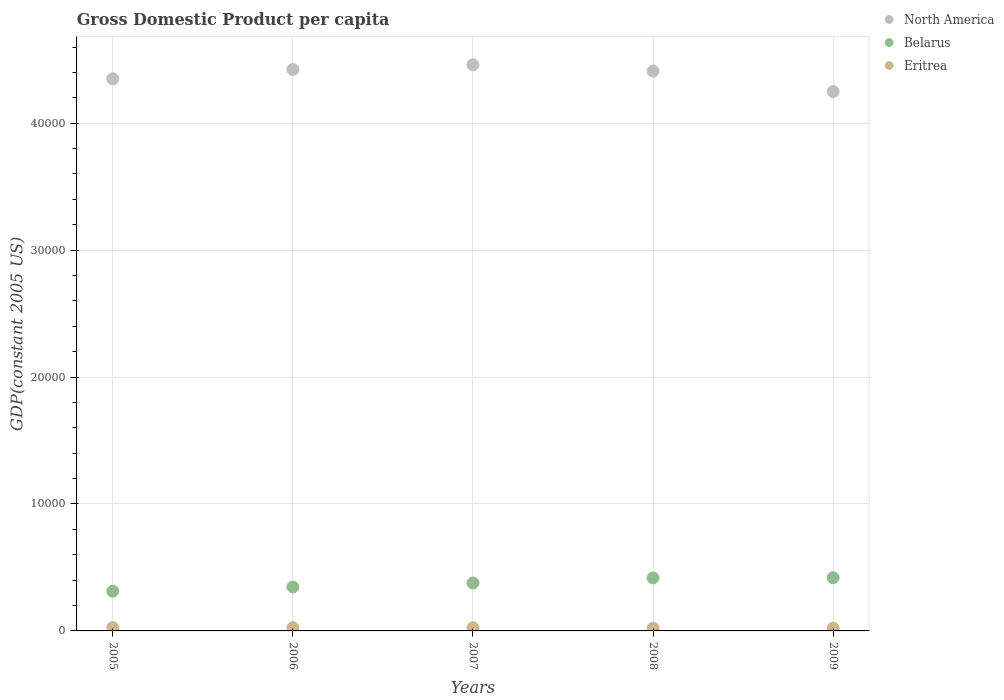Is the number of dotlines equal to the number of legend labels?
Your response must be concise. Yes. What is the GDP per capita in North America in 2005?
Provide a short and direct response. 4.35e+04. Across all years, what is the maximum GDP per capita in Eritrea?
Offer a very short reply. 262.07. Across all years, what is the minimum GDP per capita in Belarus?
Your answer should be compact. 3126.37. What is the total GDP per capita in Belarus in the graph?
Your answer should be compact. 1.87e+04. What is the difference between the GDP per capita in Eritrea in 2008 and that in 2009?
Your answer should be very brief. -3.93. What is the difference between the GDP per capita in Eritrea in 2006 and the GDP per capita in Belarus in 2009?
Offer a terse response. -3938.89. What is the average GDP per capita in North America per year?
Offer a terse response. 4.38e+04. In the year 2006, what is the difference between the GDP per capita in North America and GDP per capita in Eritrea?
Provide a succinct answer. 4.40e+04. In how many years, is the GDP per capita in Belarus greater than 26000 US$?
Provide a succinct answer. 0. What is the ratio of the GDP per capita in North America in 2008 to that in 2009?
Make the answer very short. 1.04. Is the difference between the GDP per capita in North America in 2006 and 2009 greater than the difference between the GDP per capita in Eritrea in 2006 and 2009?
Offer a terse response. Yes. What is the difference between the highest and the second highest GDP per capita in Eritrea?
Your answer should be very brief. 9.36. What is the difference between the highest and the lowest GDP per capita in Eritrea?
Your answer should be very brief. 40.91. In how many years, is the GDP per capita in North America greater than the average GDP per capita in North America taken over all years?
Keep it short and to the point. 3. Is the GDP per capita in North America strictly less than the GDP per capita in Eritrea over the years?
Give a very brief answer. No. How many dotlines are there?
Ensure brevity in your answer.  3. Are the values on the major ticks of Y-axis written in scientific E-notation?
Provide a short and direct response. No. Does the graph contain any zero values?
Offer a very short reply. No. Where does the legend appear in the graph?
Your response must be concise. Top right. How many legend labels are there?
Give a very brief answer. 3. What is the title of the graph?
Your answer should be very brief. Gross Domestic Product per capita. Does "Kenya" appear as one of the legend labels in the graph?
Keep it short and to the point. No. What is the label or title of the X-axis?
Offer a very short reply. Years. What is the label or title of the Y-axis?
Give a very brief answer. GDP(constant 2005 US). What is the GDP(constant 2005 US) in North America in 2005?
Keep it short and to the point. 4.35e+04. What is the GDP(constant 2005 US) of Belarus in 2005?
Offer a very short reply. 3126.37. What is the GDP(constant 2005 US) of Eritrea in 2005?
Your answer should be very brief. 262.07. What is the GDP(constant 2005 US) of North America in 2006?
Offer a terse response. 4.42e+04. What is the GDP(constant 2005 US) in Belarus in 2006?
Provide a succinct answer. 3460.13. What is the GDP(constant 2005 US) in Eritrea in 2006?
Provide a succinct answer. 252.71. What is the GDP(constant 2005 US) of North America in 2007?
Make the answer very short. 4.46e+04. What is the GDP(constant 2005 US) in Belarus in 2007?
Offer a terse response. 3775. What is the GDP(constant 2005 US) in Eritrea in 2007?
Your answer should be compact. 250.39. What is the GDP(constant 2005 US) in North America in 2008?
Provide a short and direct response. 4.41e+04. What is the GDP(constant 2005 US) in Belarus in 2008?
Keep it short and to the point. 4174.02. What is the GDP(constant 2005 US) in Eritrea in 2008?
Offer a terse response. 221.16. What is the GDP(constant 2005 US) of North America in 2009?
Provide a short and direct response. 4.25e+04. What is the GDP(constant 2005 US) of Belarus in 2009?
Provide a succinct answer. 4191.61. What is the GDP(constant 2005 US) of Eritrea in 2009?
Give a very brief answer. 225.09. Across all years, what is the maximum GDP(constant 2005 US) of North America?
Offer a very short reply. 4.46e+04. Across all years, what is the maximum GDP(constant 2005 US) in Belarus?
Your answer should be compact. 4191.61. Across all years, what is the maximum GDP(constant 2005 US) in Eritrea?
Your response must be concise. 262.07. Across all years, what is the minimum GDP(constant 2005 US) of North America?
Your answer should be very brief. 4.25e+04. Across all years, what is the minimum GDP(constant 2005 US) of Belarus?
Your answer should be compact. 3126.37. Across all years, what is the minimum GDP(constant 2005 US) of Eritrea?
Offer a terse response. 221.16. What is the total GDP(constant 2005 US) in North America in the graph?
Your answer should be very brief. 2.19e+05. What is the total GDP(constant 2005 US) of Belarus in the graph?
Give a very brief answer. 1.87e+04. What is the total GDP(constant 2005 US) in Eritrea in the graph?
Ensure brevity in your answer.  1211.42. What is the difference between the GDP(constant 2005 US) of North America in 2005 and that in 2006?
Keep it short and to the point. -737.56. What is the difference between the GDP(constant 2005 US) of Belarus in 2005 and that in 2006?
Your response must be concise. -333.76. What is the difference between the GDP(constant 2005 US) in Eritrea in 2005 and that in 2006?
Your response must be concise. 9.36. What is the difference between the GDP(constant 2005 US) of North America in 2005 and that in 2007?
Give a very brief answer. -1105.75. What is the difference between the GDP(constant 2005 US) in Belarus in 2005 and that in 2007?
Make the answer very short. -648.63. What is the difference between the GDP(constant 2005 US) of Eritrea in 2005 and that in 2007?
Offer a very short reply. 11.68. What is the difference between the GDP(constant 2005 US) of North America in 2005 and that in 2008?
Provide a short and direct response. -604.38. What is the difference between the GDP(constant 2005 US) in Belarus in 2005 and that in 2008?
Offer a terse response. -1047.65. What is the difference between the GDP(constant 2005 US) in Eritrea in 2005 and that in 2008?
Offer a very short reply. 40.91. What is the difference between the GDP(constant 2005 US) in North America in 2005 and that in 2009?
Keep it short and to the point. 1003.24. What is the difference between the GDP(constant 2005 US) in Belarus in 2005 and that in 2009?
Your response must be concise. -1065.24. What is the difference between the GDP(constant 2005 US) of Eritrea in 2005 and that in 2009?
Make the answer very short. 36.99. What is the difference between the GDP(constant 2005 US) of North America in 2006 and that in 2007?
Keep it short and to the point. -368.19. What is the difference between the GDP(constant 2005 US) in Belarus in 2006 and that in 2007?
Your answer should be compact. -314.87. What is the difference between the GDP(constant 2005 US) in Eritrea in 2006 and that in 2007?
Provide a succinct answer. 2.32. What is the difference between the GDP(constant 2005 US) in North America in 2006 and that in 2008?
Keep it short and to the point. 133.18. What is the difference between the GDP(constant 2005 US) in Belarus in 2006 and that in 2008?
Keep it short and to the point. -713.89. What is the difference between the GDP(constant 2005 US) in Eritrea in 2006 and that in 2008?
Give a very brief answer. 31.55. What is the difference between the GDP(constant 2005 US) of North America in 2006 and that in 2009?
Provide a succinct answer. 1740.8. What is the difference between the GDP(constant 2005 US) in Belarus in 2006 and that in 2009?
Offer a very short reply. -731.47. What is the difference between the GDP(constant 2005 US) of Eritrea in 2006 and that in 2009?
Give a very brief answer. 27.62. What is the difference between the GDP(constant 2005 US) in North America in 2007 and that in 2008?
Give a very brief answer. 501.37. What is the difference between the GDP(constant 2005 US) of Belarus in 2007 and that in 2008?
Provide a succinct answer. -399.02. What is the difference between the GDP(constant 2005 US) of Eritrea in 2007 and that in 2008?
Your answer should be compact. 29.23. What is the difference between the GDP(constant 2005 US) of North America in 2007 and that in 2009?
Your response must be concise. 2108.99. What is the difference between the GDP(constant 2005 US) of Belarus in 2007 and that in 2009?
Offer a very short reply. -416.61. What is the difference between the GDP(constant 2005 US) in Eritrea in 2007 and that in 2009?
Ensure brevity in your answer.  25.3. What is the difference between the GDP(constant 2005 US) of North America in 2008 and that in 2009?
Your response must be concise. 1607.62. What is the difference between the GDP(constant 2005 US) of Belarus in 2008 and that in 2009?
Provide a short and direct response. -17.59. What is the difference between the GDP(constant 2005 US) in Eritrea in 2008 and that in 2009?
Make the answer very short. -3.93. What is the difference between the GDP(constant 2005 US) in North America in 2005 and the GDP(constant 2005 US) in Belarus in 2006?
Ensure brevity in your answer.  4.00e+04. What is the difference between the GDP(constant 2005 US) of North America in 2005 and the GDP(constant 2005 US) of Eritrea in 2006?
Give a very brief answer. 4.32e+04. What is the difference between the GDP(constant 2005 US) of Belarus in 2005 and the GDP(constant 2005 US) of Eritrea in 2006?
Offer a very short reply. 2873.66. What is the difference between the GDP(constant 2005 US) of North America in 2005 and the GDP(constant 2005 US) of Belarus in 2007?
Your answer should be very brief. 3.97e+04. What is the difference between the GDP(constant 2005 US) in North America in 2005 and the GDP(constant 2005 US) in Eritrea in 2007?
Give a very brief answer. 4.32e+04. What is the difference between the GDP(constant 2005 US) in Belarus in 2005 and the GDP(constant 2005 US) in Eritrea in 2007?
Your answer should be compact. 2875.98. What is the difference between the GDP(constant 2005 US) of North America in 2005 and the GDP(constant 2005 US) of Belarus in 2008?
Offer a very short reply. 3.93e+04. What is the difference between the GDP(constant 2005 US) of North America in 2005 and the GDP(constant 2005 US) of Eritrea in 2008?
Your response must be concise. 4.33e+04. What is the difference between the GDP(constant 2005 US) of Belarus in 2005 and the GDP(constant 2005 US) of Eritrea in 2008?
Your response must be concise. 2905.21. What is the difference between the GDP(constant 2005 US) of North America in 2005 and the GDP(constant 2005 US) of Belarus in 2009?
Give a very brief answer. 3.93e+04. What is the difference between the GDP(constant 2005 US) in North America in 2005 and the GDP(constant 2005 US) in Eritrea in 2009?
Make the answer very short. 4.33e+04. What is the difference between the GDP(constant 2005 US) of Belarus in 2005 and the GDP(constant 2005 US) of Eritrea in 2009?
Offer a very short reply. 2901.28. What is the difference between the GDP(constant 2005 US) in North America in 2006 and the GDP(constant 2005 US) in Belarus in 2007?
Your response must be concise. 4.05e+04. What is the difference between the GDP(constant 2005 US) in North America in 2006 and the GDP(constant 2005 US) in Eritrea in 2007?
Your answer should be compact. 4.40e+04. What is the difference between the GDP(constant 2005 US) in Belarus in 2006 and the GDP(constant 2005 US) in Eritrea in 2007?
Give a very brief answer. 3209.74. What is the difference between the GDP(constant 2005 US) in North America in 2006 and the GDP(constant 2005 US) in Belarus in 2008?
Provide a succinct answer. 4.01e+04. What is the difference between the GDP(constant 2005 US) of North America in 2006 and the GDP(constant 2005 US) of Eritrea in 2008?
Provide a succinct answer. 4.40e+04. What is the difference between the GDP(constant 2005 US) of Belarus in 2006 and the GDP(constant 2005 US) of Eritrea in 2008?
Make the answer very short. 3238.97. What is the difference between the GDP(constant 2005 US) in North America in 2006 and the GDP(constant 2005 US) in Belarus in 2009?
Your response must be concise. 4.00e+04. What is the difference between the GDP(constant 2005 US) in North America in 2006 and the GDP(constant 2005 US) in Eritrea in 2009?
Offer a terse response. 4.40e+04. What is the difference between the GDP(constant 2005 US) of Belarus in 2006 and the GDP(constant 2005 US) of Eritrea in 2009?
Your answer should be compact. 3235.04. What is the difference between the GDP(constant 2005 US) of North America in 2007 and the GDP(constant 2005 US) of Belarus in 2008?
Ensure brevity in your answer.  4.04e+04. What is the difference between the GDP(constant 2005 US) in North America in 2007 and the GDP(constant 2005 US) in Eritrea in 2008?
Provide a succinct answer. 4.44e+04. What is the difference between the GDP(constant 2005 US) of Belarus in 2007 and the GDP(constant 2005 US) of Eritrea in 2008?
Offer a very short reply. 3553.84. What is the difference between the GDP(constant 2005 US) of North America in 2007 and the GDP(constant 2005 US) of Belarus in 2009?
Keep it short and to the point. 4.04e+04. What is the difference between the GDP(constant 2005 US) in North America in 2007 and the GDP(constant 2005 US) in Eritrea in 2009?
Offer a terse response. 4.44e+04. What is the difference between the GDP(constant 2005 US) of Belarus in 2007 and the GDP(constant 2005 US) of Eritrea in 2009?
Your answer should be very brief. 3549.91. What is the difference between the GDP(constant 2005 US) of North America in 2008 and the GDP(constant 2005 US) of Belarus in 2009?
Provide a succinct answer. 3.99e+04. What is the difference between the GDP(constant 2005 US) of North America in 2008 and the GDP(constant 2005 US) of Eritrea in 2009?
Keep it short and to the point. 4.39e+04. What is the difference between the GDP(constant 2005 US) in Belarus in 2008 and the GDP(constant 2005 US) in Eritrea in 2009?
Your response must be concise. 3948.93. What is the average GDP(constant 2005 US) in North America per year?
Your response must be concise. 4.38e+04. What is the average GDP(constant 2005 US) of Belarus per year?
Offer a very short reply. 3745.42. What is the average GDP(constant 2005 US) in Eritrea per year?
Keep it short and to the point. 242.28. In the year 2005, what is the difference between the GDP(constant 2005 US) of North America and GDP(constant 2005 US) of Belarus?
Your response must be concise. 4.04e+04. In the year 2005, what is the difference between the GDP(constant 2005 US) of North America and GDP(constant 2005 US) of Eritrea?
Your response must be concise. 4.32e+04. In the year 2005, what is the difference between the GDP(constant 2005 US) of Belarus and GDP(constant 2005 US) of Eritrea?
Offer a terse response. 2864.29. In the year 2006, what is the difference between the GDP(constant 2005 US) of North America and GDP(constant 2005 US) of Belarus?
Your answer should be very brief. 4.08e+04. In the year 2006, what is the difference between the GDP(constant 2005 US) in North America and GDP(constant 2005 US) in Eritrea?
Give a very brief answer. 4.40e+04. In the year 2006, what is the difference between the GDP(constant 2005 US) of Belarus and GDP(constant 2005 US) of Eritrea?
Keep it short and to the point. 3207.42. In the year 2007, what is the difference between the GDP(constant 2005 US) of North America and GDP(constant 2005 US) of Belarus?
Your response must be concise. 4.08e+04. In the year 2007, what is the difference between the GDP(constant 2005 US) of North America and GDP(constant 2005 US) of Eritrea?
Ensure brevity in your answer.  4.44e+04. In the year 2007, what is the difference between the GDP(constant 2005 US) of Belarus and GDP(constant 2005 US) of Eritrea?
Provide a short and direct response. 3524.61. In the year 2008, what is the difference between the GDP(constant 2005 US) of North America and GDP(constant 2005 US) of Belarus?
Offer a very short reply. 3.99e+04. In the year 2008, what is the difference between the GDP(constant 2005 US) in North America and GDP(constant 2005 US) in Eritrea?
Make the answer very short. 4.39e+04. In the year 2008, what is the difference between the GDP(constant 2005 US) in Belarus and GDP(constant 2005 US) in Eritrea?
Offer a terse response. 3952.86. In the year 2009, what is the difference between the GDP(constant 2005 US) of North America and GDP(constant 2005 US) of Belarus?
Ensure brevity in your answer.  3.83e+04. In the year 2009, what is the difference between the GDP(constant 2005 US) of North America and GDP(constant 2005 US) of Eritrea?
Provide a succinct answer. 4.23e+04. In the year 2009, what is the difference between the GDP(constant 2005 US) in Belarus and GDP(constant 2005 US) in Eritrea?
Offer a terse response. 3966.52. What is the ratio of the GDP(constant 2005 US) in North America in 2005 to that in 2006?
Offer a very short reply. 0.98. What is the ratio of the GDP(constant 2005 US) in Belarus in 2005 to that in 2006?
Your answer should be very brief. 0.9. What is the ratio of the GDP(constant 2005 US) in Eritrea in 2005 to that in 2006?
Make the answer very short. 1.04. What is the ratio of the GDP(constant 2005 US) of North America in 2005 to that in 2007?
Ensure brevity in your answer.  0.98. What is the ratio of the GDP(constant 2005 US) in Belarus in 2005 to that in 2007?
Provide a succinct answer. 0.83. What is the ratio of the GDP(constant 2005 US) of Eritrea in 2005 to that in 2007?
Offer a very short reply. 1.05. What is the ratio of the GDP(constant 2005 US) of North America in 2005 to that in 2008?
Your answer should be very brief. 0.99. What is the ratio of the GDP(constant 2005 US) of Belarus in 2005 to that in 2008?
Keep it short and to the point. 0.75. What is the ratio of the GDP(constant 2005 US) in Eritrea in 2005 to that in 2008?
Your response must be concise. 1.19. What is the ratio of the GDP(constant 2005 US) in North America in 2005 to that in 2009?
Your answer should be compact. 1.02. What is the ratio of the GDP(constant 2005 US) of Belarus in 2005 to that in 2009?
Provide a succinct answer. 0.75. What is the ratio of the GDP(constant 2005 US) in Eritrea in 2005 to that in 2009?
Ensure brevity in your answer.  1.16. What is the ratio of the GDP(constant 2005 US) in Belarus in 2006 to that in 2007?
Offer a terse response. 0.92. What is the ratio of the GDP(constant 2005 US) in Eritrea in 2006 to that in 2007?
Provide a succinct answer. 1.01. What is the ratio of the GDP(constant 2005 US) of North America in 2006 to that in 2008?
Keep it short and to the point. 1. What is the ratio of the GDP(constant 2005 US) of Belarus in 2006 to that in 2008?
Provide a succinct answer. 0.83. What is the ratio of the GDP(constant 2005 US) of Eritrea in 2006 to that in 2008?
Provide a short and direct response. 1.14. What is the ratio of the GDP(constant 2005 US) of North America in 2006 to that in 2009?
Provide a short and direct response. 1.04. What is the ratio of the GDP(constant 2005 US) in Belarus in 2006 to that in 2009?
Provide a short and direct response. 0.83. What is the ratio of the GDP(constant 2005 US) in Eritrea in 2006 to that in 2009?
Provide a succinct answer. 1.12. What is the ratio of the GDP(constant 2005 US) in North America in 2007 to that in 2008?
Give a very brief answer. 1.01. What is the ratio of the GDP(constant 2005 US) of Belarus in 2007 to that in 2008?
Your response must be concise. 0.9. What is the ratio of the GDP(constant 2005 US) in Eritrea in 2007 to that in 2008?
Keep it short and to the point. 1.13. What is the ratio of the GDP(constant 2005 US) of North America in 2007 to that in 2009?
Your response must be concise. 1.05. What is the ratio of the GDP(constant 2005 US) in Belarus in 2007 to that in 2009?
Provide a short and direct response. 0.9. What is the ratio of the GDP(constant 2005 US) in Eritrea in 2007 to that in 2009?
Give a very brief answer. 1.11. What is the ratio of the GDP(constant 2005 US) in North America in 2008 to that in 2009?
Provide a short and direct response. 1.04. What is the ratio of the GDP(constant 2005 US) of Eritrea in 2008 to that in 2009?
Ensure brevity in your answer.  0.98. What is the difference between the highest and the second highest GDP(constant 2005 US) in North America?
Your answer should be very brief. 368.19. What is the difference between the highest and the second highest GDP(constant 2005 US) in Belarus?
Provide a short and direct response. 17.59. What is the difference between the highest and the second highest GDP(constant 2005 US) of Eritrea?
Your answer should be very brief. 9.36. What is the difference between the highest and the lowest GDP(constant 2005 US) in North America?
Give a very brief answer. 2108.99. What is the difference between the highest and the lowest GDP(constant 2005 US) of Belarus?
Your answer should be very brief. 1065.24. What is the difference between the highest and the lowest GDP(constant 2005 US) of Eritrea?
Your answer should be compact. 40.91. 